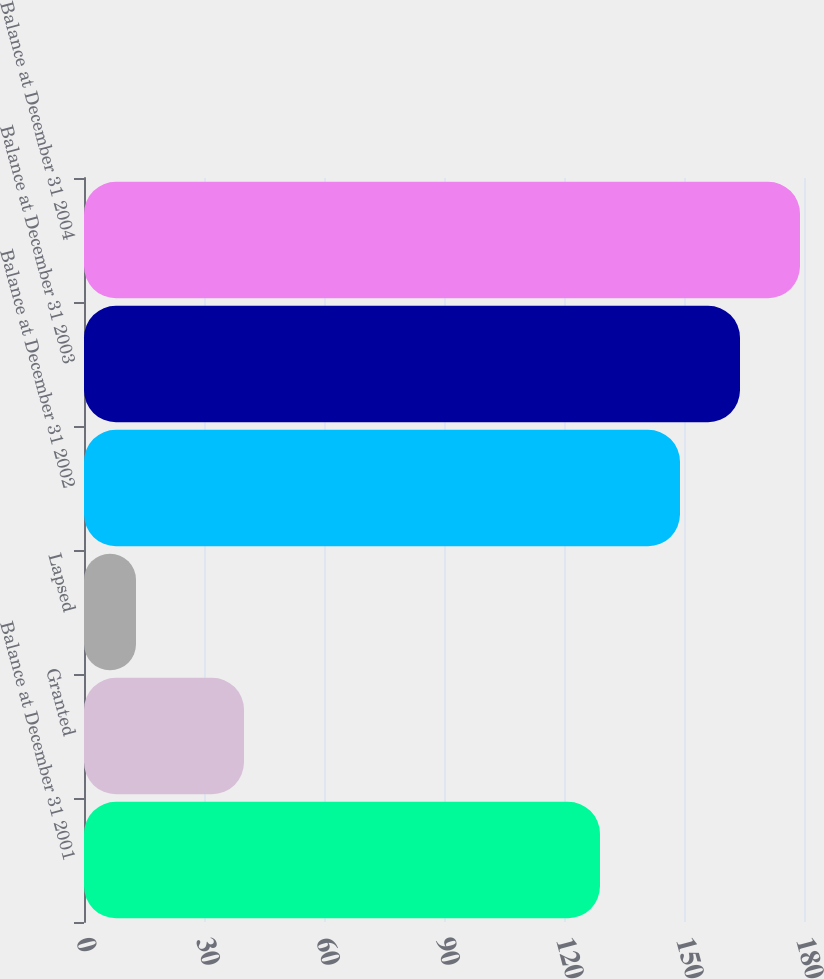Convert chart to OTSL. <chart><loc_0><loc_0><loc_500><loc_500><bar_chart><fcel>Balance at December 31 2001<fcel>Granted<fcel>Lapsed<fcel>Balance at December 31 2002<fcel>Balance at December 31 2003<fcel>Balance at December 31 2004<nl><fcel>129<fcel>40<fcel>13<fcel>149<fcel>164<fcel>179<nl></chart> 